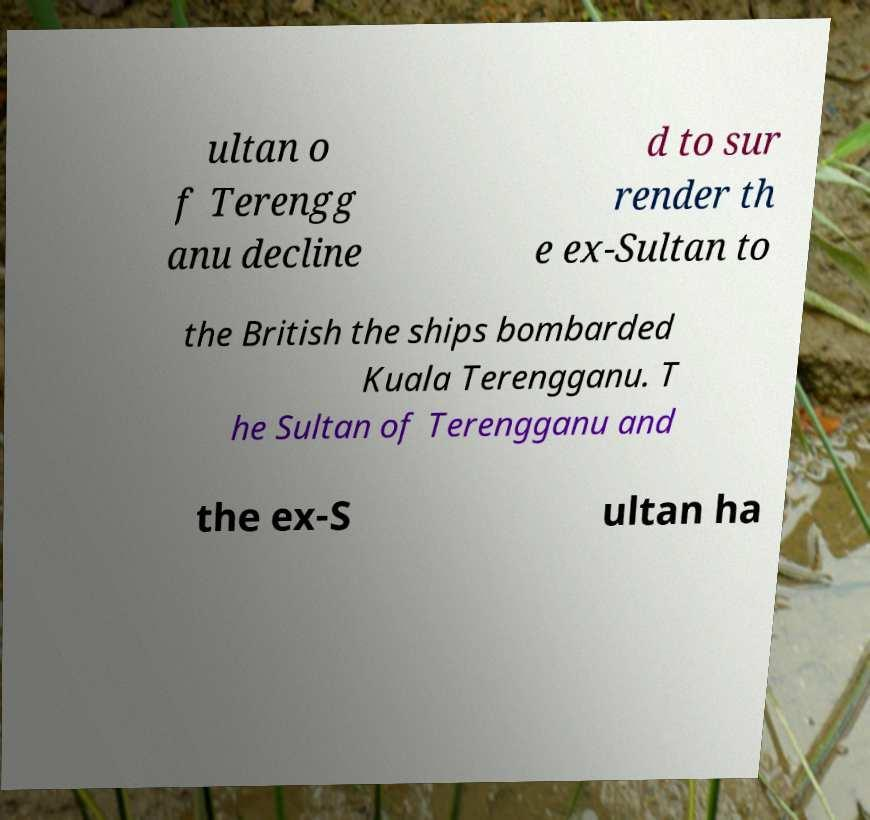Can you read and provide the text displayed in the image?This photo seems to have some interesting text. Can you extract and type it out for me? ultan o f Terengg anu decline d to sur render th e ex-Sultan to the British the ships bombarded Kuala Terengganu. T he Sultan of Terengganu and the ex-S ultan ha 